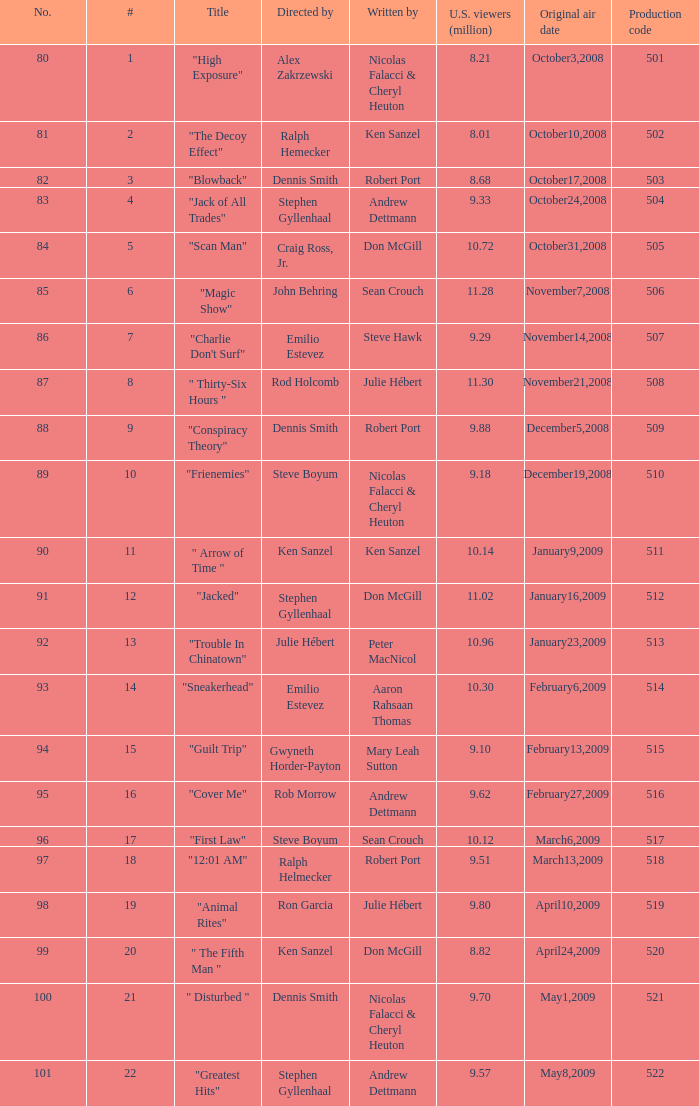Give me the full table as a dictionary. {'header': ['No.', '#', 'Title', 'Directed by', 'Written by', 'U.S. viewers (million)', 'Original air date', 'Production code'], 'rows': [['80', '1', '"High Exposure"', 'Alex Zakrzewski', 'Nicolas Falacci & Cheryl Heuton', '8.21', 'October3,2008', '501'], ['81', '2', '"The Decoy Effect"', 'Ralph Hemecker', 'Ken Sanzel', '8.01', 'October10,2008', '502'], ['82', '3', '"Blowback"', 'Dennis Smith', 'Robert Port', '8.68', 'October17,2008', '503'], ['83', '4', '"Jack of All Trades"', 'Stephen Gyllenhaal', 'Andrew Dettmann', '9.33', 'October24,2008', '504'], ['84', '5', '"Scan Man"', 'Craig Ross, Jr.', 'Don McGill', '10.72', 'October31,2008', '505'], ['85', '6', '"Magic Show"', 'John Behring', 'Sean Crouch', '11.28', 'November7,2008', '506'], ['86', '7', '"Charlie Don\'t Surf"', 'Emilio Estevez', 'Steve Hawk', '9.29', 'November14,2008', '507'], ['87', '8', '" Thirty-Six Hours "', 'Rod Holcomb', 'Julie Hébert', '11.30', 'November21,2008', '508'], ['88', '9', '"Conspiracy Theory"', 'Dennis Smith', 'Robert Port', '9.88', 'December5,2008', '509'], ['89', '10', '"Frienemies"', 'Steve Boyum', 'Nicolas Falacci & Cheryl Heuton', '9.18', 'December19,2008', '510'], ['90', '11', '" Arrow of Time "', 'Ken Sanzel', 'Ken Sanzel', '10.14', 'January9,2009', '511'], ['91', '12', '"Jacked"', 'Stephen Gyllenhaal', 'Don McGill', '11.02', 'January16,2009', '512'], ['92', '13', '"Trouble In Chinatown"', 'Julie Hébert', 'Peter MacNicol', '10.96', 'January23,2009', '513'], ['93', '14', '"Sneakerhead"', 'Emilio Estevez', 'Aaron Rahsaan Thomas', '10.30', 'February6,2009', '514'], ['94', '15', '"Guilt Trip"', 'Gwyneth Horder-Payton', 'Mary Leah Sutton', '9.10', 'February13,2009', '515'], ['95', '16', '"Cover Me"', 'Rob Morrow', 'Andrew Dettmann', '9.62', 'February27,2009', '516'], ['96', '17', '"First Law"', 'Steve Boyum', 'Sean Crouch', '10.12', 'March6,2009', '517'], ['97', '18', '"12:01 AM"', 'Ralph Helmecker', 'Robert Port', '9.51', 'March13,2009', '518'], ['98', '19', '"Animal Rites"', 'Ron Garcia', 'Julie Hébert', '9.80', 'April10,2009', '519'], ['99', '20', '" The Fifth Man "', 'Ken Sanzel', 'Don McGill', '8.82', 'April24,2009', '520'], ['100', '21', '" Disturbed "', 'Dennis Smith', 'Nicolas Falacci & Cheryl Heuton', '9.70', 'May1,2009', '521'], ['101', '22', '"Greatest Hits"', 'Stephen Gyllenhaal', 'Andrew Dettmann', '9.57', 'May8,2009', '522']]} 18 million viewers (u.s.)? 510.0. 